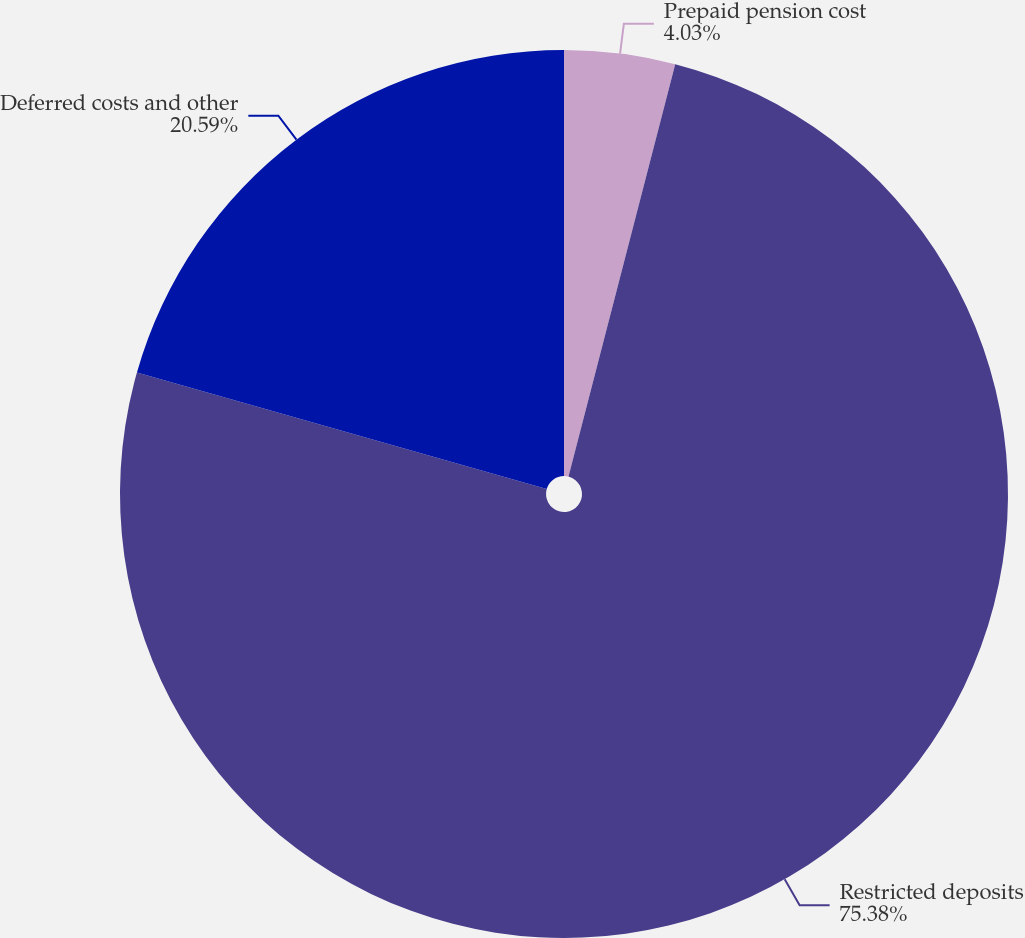Convert chart to OTSL. <chart><loc_0><loc_0><loc_500><loc_500><pie_chart><fcel>Prepaid pension cost<fcel>Restricted deposits<fcel>Deferred costs and other<nl><fcel>4.03%<fcel>75.38%<fcel>20.59%<nl></chart> 